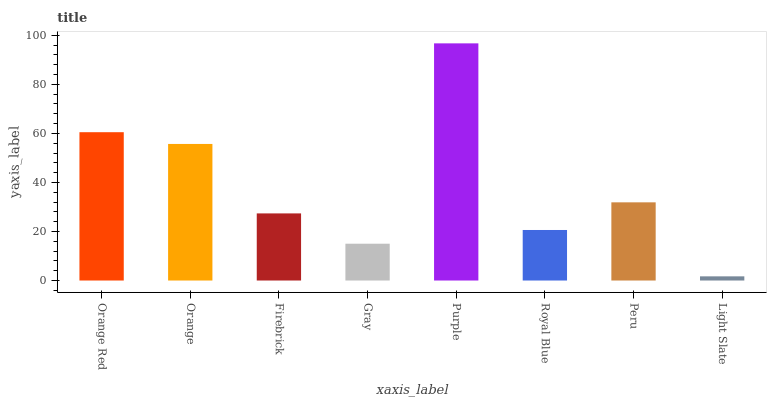Is Orange the minimum?
Answer yes or no. No. Is Orange the maximum?
Answer yes or no. No. Is Orange Red greater than Orange?
Answer yes or no. Yes. Is Orange less than Orange Red?
Answer yes or no. Yes. Is Orange greater than Orange Red?
Answer yes or no. No. Is Orange Red less than Orange?
Answer yes or no. No. Is Peru the high median?
Answer yes or no. Yes. Is Firebrick the low median?
Answer yes or no. Yes. Is Orange Red the high median?
Answer yes or no. No. Is Peru the low median?
Answer yes or no. No. 